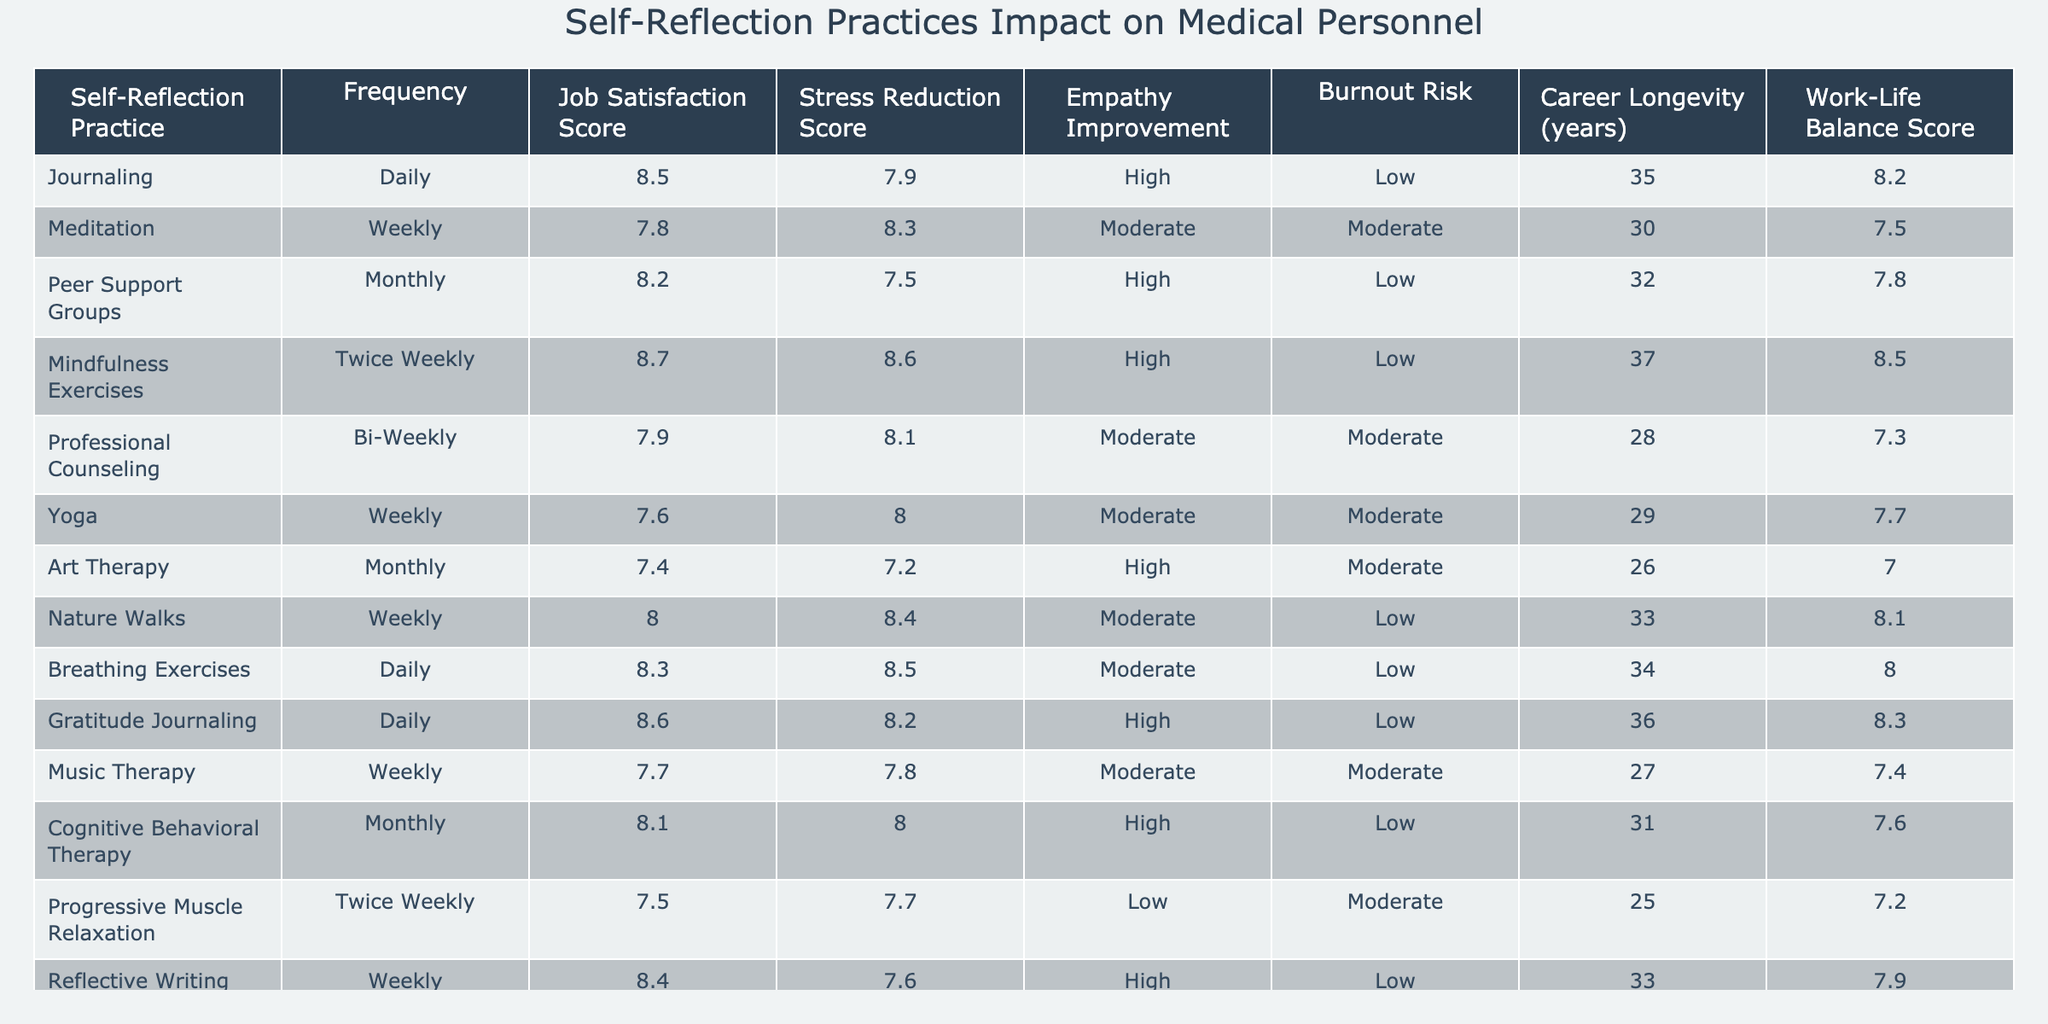What is the job satisfaction score for meditation? The table indicates that the job satisfaction score for meditation is listed directly next to the entry for meditation, which shows a score of 7.8.
Answer: 7.8 Which self-reflection practice has the highest frequency? The frequency of self-reflection practices is listed in the second column. Journaling and Breathing Exercises both have a frequency of Daily, making them the most frequent practices listed.
Answer: Journaling and Breathing Exercises What is the average job satisfaction score for practices that include high empathy improvement? The practices with high empathy improvement are Journaling, Peer Support Groups, Mindfulness Exercises, Gratitude Journaling, Cognitive Behavioral Therapy, and Art Therapy. Their job satisfaction scores are 8.5, 8.2, 8.7, 8.6, 8.1, and 7.4. The average is (8.5 + 8.2 + 8.7 + 8.6 + 8.1 + 7.4) / 6 = 8.4333.
Answer: 8.43 How many self-reflection practices scored a burnout risk of Low? We can go through the table and count the practices that have a burnout risk labeled as Low. These practices are Journaling, Peer Support Groups, Mindfulness Exercises, Breathing Exercises, and Nature Walks, which totals to 5.
Answer: 5 Is there any practice with a career longevity greater than 35 years? Looking through the career longevity column, we see that both Mindfulness Exercises (37 years) and Journaling (35 years) have values greater than or equal to 35 years. Thus, we can conclude that there are practices with career longevity equal to or above 35 years.
Answer: Yes What is the difference in stress reduction scores between Yoga and Nature Walks? The stress reduction score for Yoga is 8.0, and for Nature Walks, it is 8.4. To find the difference, we subtract Yoga's score from Nature Walks' score: 8.4 - 8.0 = 0.4.
Answer: 0.4 Which self-reflection practice has the lowest work-life balance score? In the work-life balance score column, we look for the lowest score indicated in the table. Art Therapy has the lowest score at 7.0.
Answer: 7.0 If the job satisfaction score is above 8, how many practices are there? We examine the job satisfaction scores in the table. The practices with scores above 8 are Journaling (8.5), Mindfulness Exercises (8.7), Gratitude Journaling (8.6), and Reflective Writing (8.4), totaling 4 practices.
Answer: 4 What practice shows both a stress reduction score of 8.3 and a job satisfaction score of at least 8? The practice that meets the criteria of having a stress reduction score of 8.3 and a job satisfaction score of 8 or above is Breathing Exercises, which has both these scores: 8.3 and 8.3, respectively.
Answer: Breathing Exercises Which self-reflection practice has moderate burnout risk but high empathy improvement? By inspecting the burnout risk and empathy improvement columns, we find that Professional Counseling is the only practice with moderate burnout risk and high empathy improvement.
Answer: Professional Counseling 